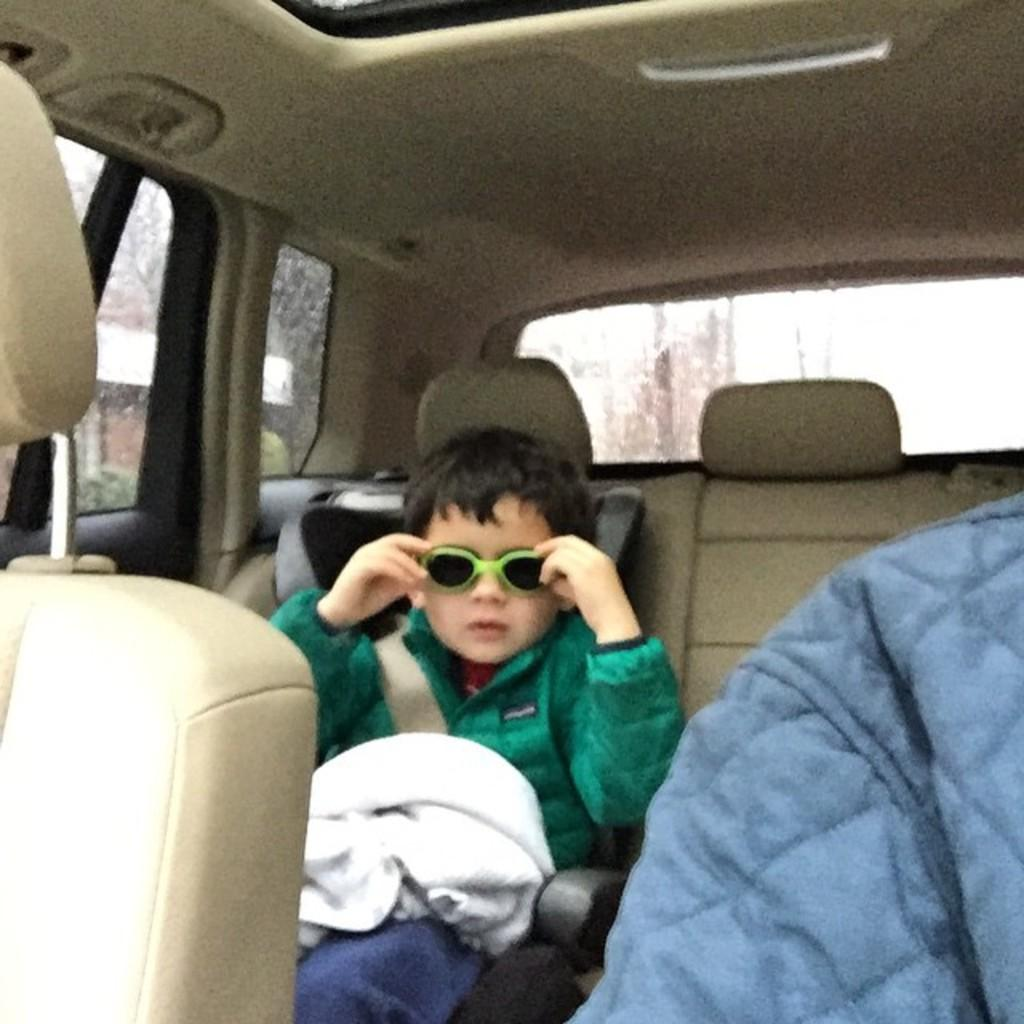Who is in the image? There is a boy in the image. What is the boy doing in the image? The boy is sitting in a car. What is the boy wearing in the image? The boy is wearing goggles. What type of instrument is the boy playing in the image? There is no instrument present in the image; the boy is simply sitting in a car and wearing goggles. 